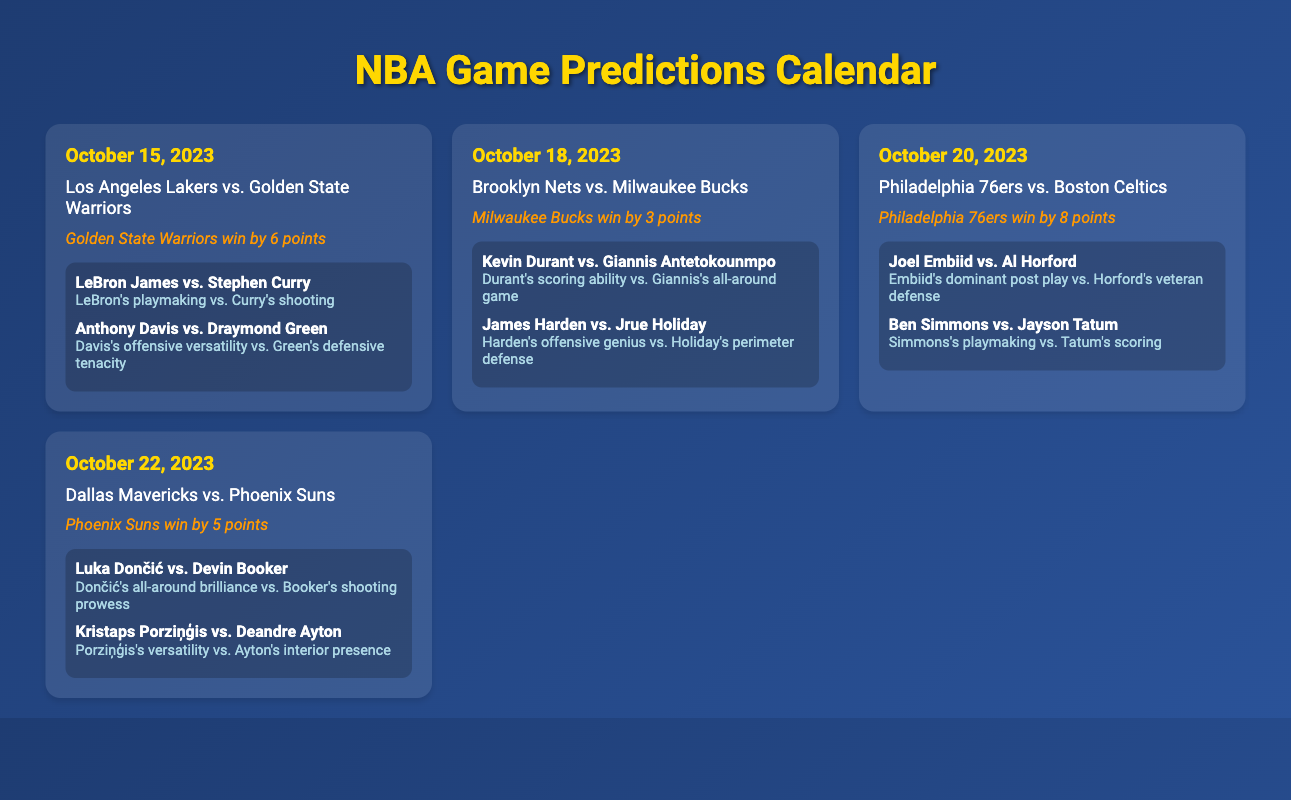What date is the game between the Los Angeles Lakers and the Golden State Warriors? The date of the game is specified in the document as October 15, 2023.
Answer: October 15, 2023 Who is predicted to win the game between the Brooklyn Nets and the Milwaukee Bucks? The prediction for the Brooklyn Nets vs. Milwaukee Bucks game is highlighted in the document.
Answer: Milwaukee Bucks How many points are the Philadelphia 76ers predicted to win by against the Boston Celtics? The predicted outcome for the Philadelphia 76ers vs. Boston Celtics indicates they will win by a specific margin.
Answer: 8 points What player matchup is highlighted for the Dallas Mavericks vs. Phoenix Suns game? The document mentions specific player matchups for each game, focusing on the key players in the matchup.
Answer: Luka Dončić vs. Devin Booker What is the primary impact of Joel Embiid in the matchup against Al Horford? The impact of Joel Embiid in the game is described in terms of his playing style compared to Al Horford's abilities.
Answer: Embiid's dominant post play Which team is playing on October 22, 2023? The document lists games along with their respective dates, indicating which teams will compete on specific dates.
Answer: Dallas Mavericks vs. Phoenix Suns What is the matchup impact of Anthony Davis against Draymond Green? The document provides insights into the player matchups and their impacts in terms of their playing styles.
Answer: Davis's offensive versatility vs. Green's defensive tenacity 